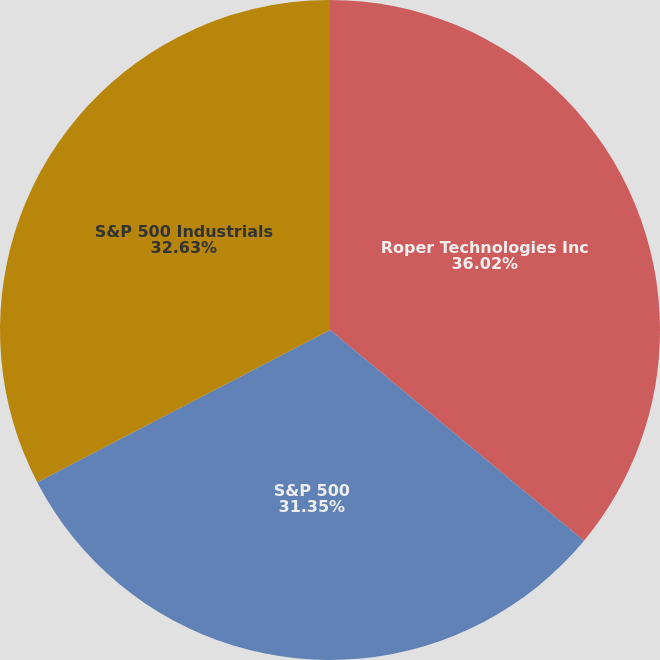Convert chart to OTSL. <chart><loc_0><loc_0><loc_500><loc_500><pie_chart><fcel>Roper Technologies Inc<fcel>S&P 500<fcel>S&P 500 Industrials<nl><fcel>36.02%<fcel>31.35%<fcel>32.63%<nl></chart> 